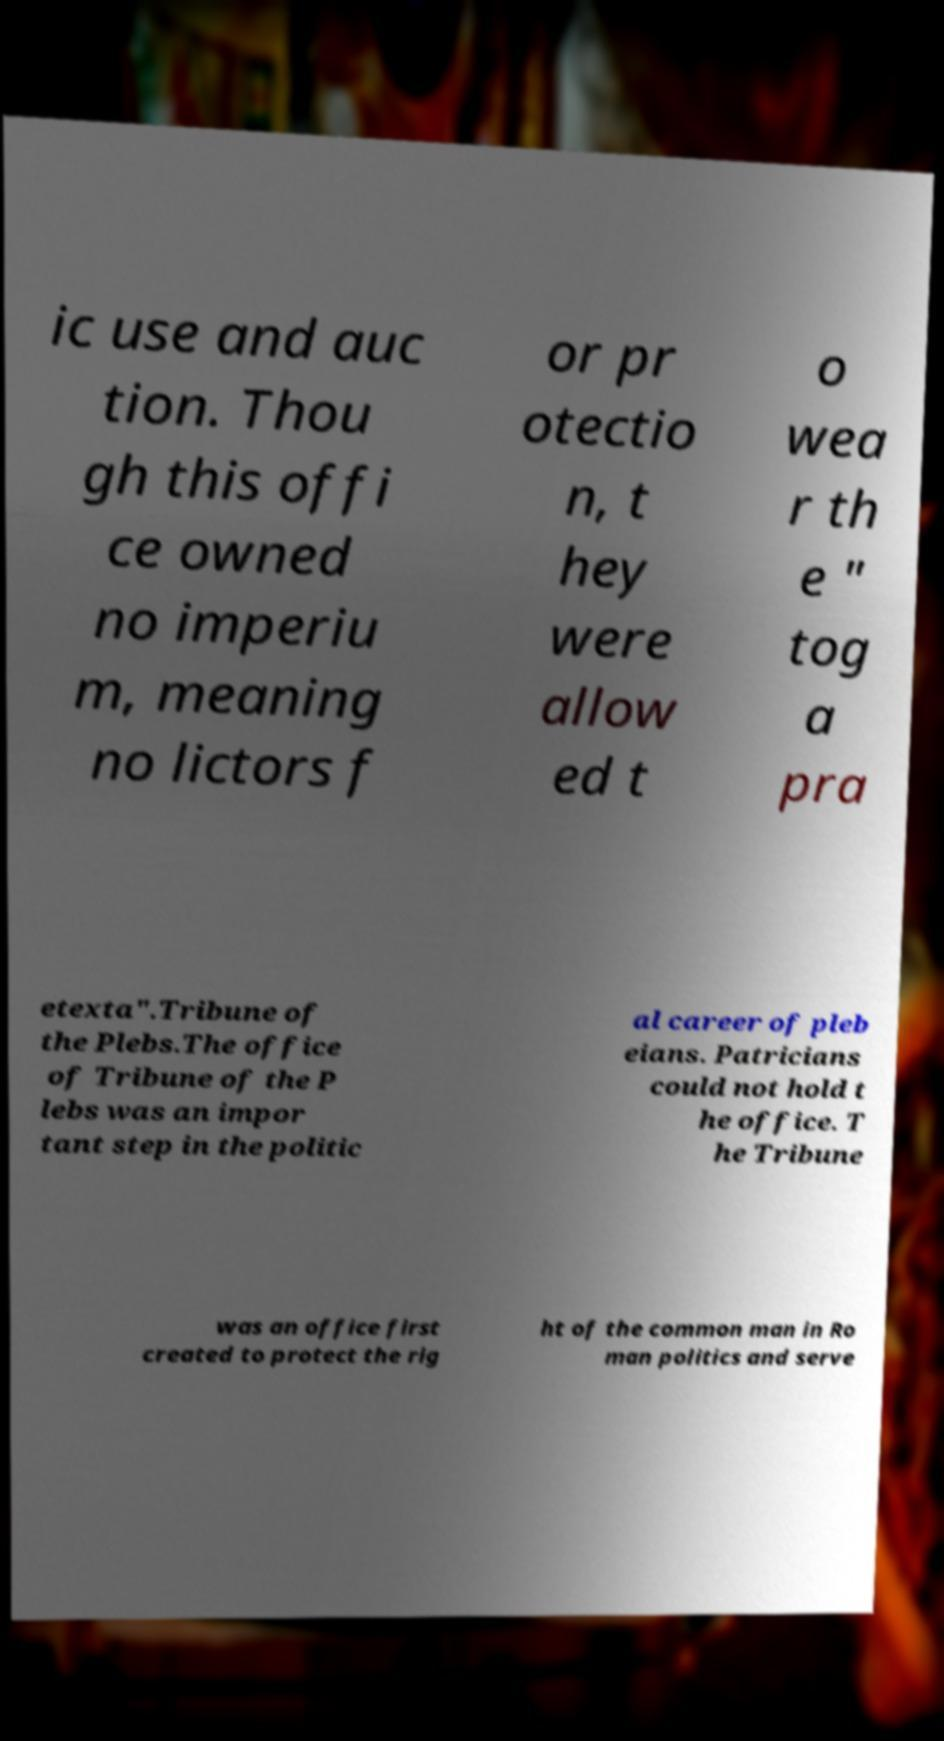For documentation purposes, I need the text within this image transcribed. Could you provide that? ic use and auc tion. Thou gh this offi ce owned no imperiu m, meaning no lictors f or pr otectio n, t hey were allow ed t o wea r th e " tog a pra etexta".Tribune of the Plebs.The office of Tribune of the P lebs was an impor tant step in the politic al career of pleb eians. Patricians could not hold t he office. T he Tribune was an office first created to protect the rig ht of the common man in Ro man politics and serve 